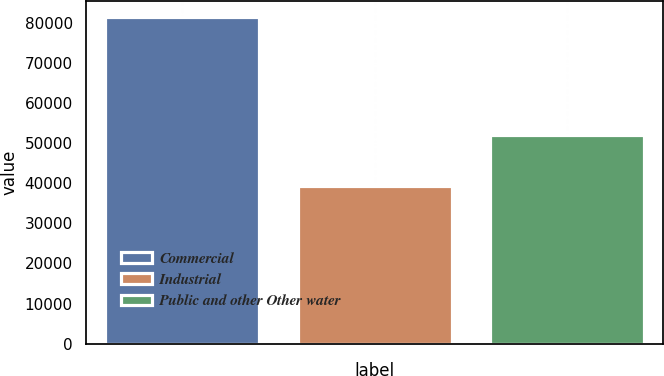Convert chart to OTSL. <chart><loc_0><loc_0><loc_500><loc_500><bar_chart><fcel>Commercial<fcel>Industrial<fcel>Public and other Other water<nl><fcel>81455<fcel>39295<fcel>52069<nl></chart> 